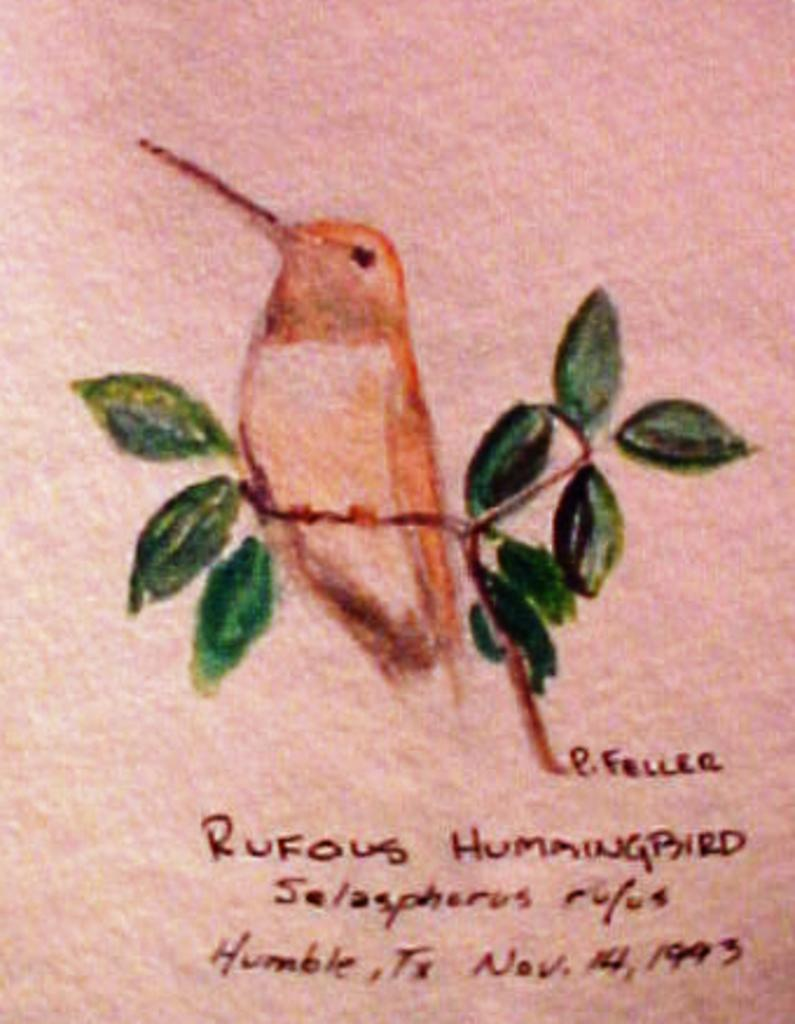What type of living organism is depicted in the drawing in the image? The image contains a drawing of a bird. What other type of living organism is depicted in the drawing in the image? The image contains a drawing of a plant. What else can be seen in the image besides the drawings? There is text written in the image. What type of hose is being used to water the plant in the image? There is no hose present in the image; it only contains drawings of a bird and a plant, along with some text. 